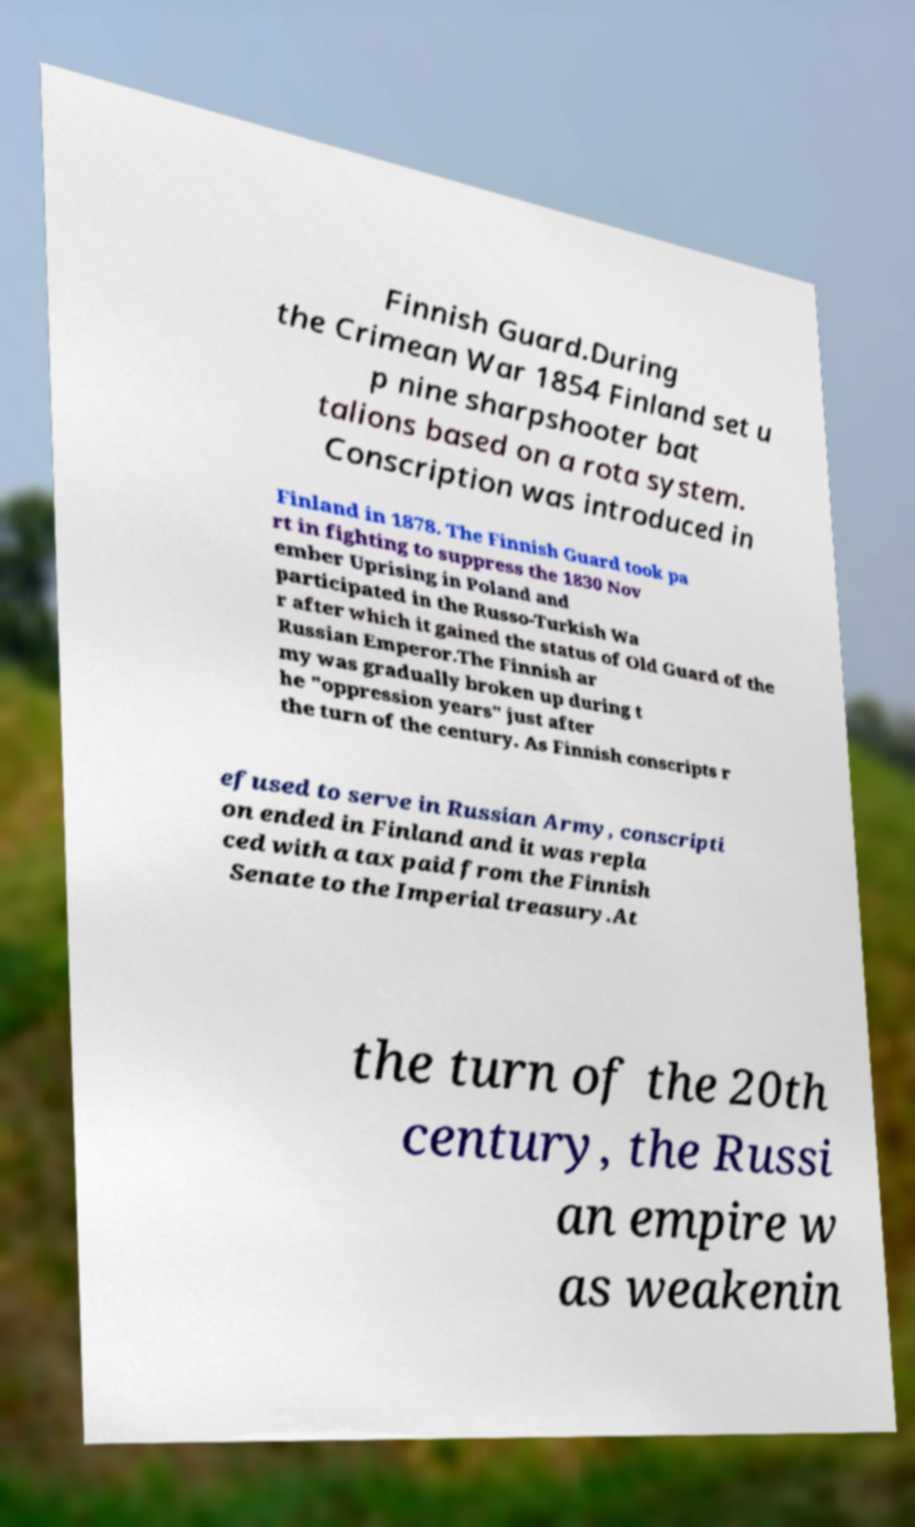Can you accurately transcribe the text from the provided image for me? Finnish Guard.During the Crimean War 1854 Finland set u p nine sharpshooter bat talions based on a rota system. Conscription was introduced in Finland in 1878. The Finnish Guard took pa rt in fighting to suppress the 1830 Nov ember Uprising in Poland and participated in the Russo-Turkish Wa r after which it gained the status of Old Guard of the Russian Emperor.The Finnish ar my was gradually broken up during t he "oppression years" just after the turn of the century. As Finnish conscripts r efused to serve in Russian Army, conscripti on ended in Finland and it was repla ced with a tax paid from the Finnish Senate to the Imperial treasury.At the turn of the 20th century, the Russi an empire w as weakenin 